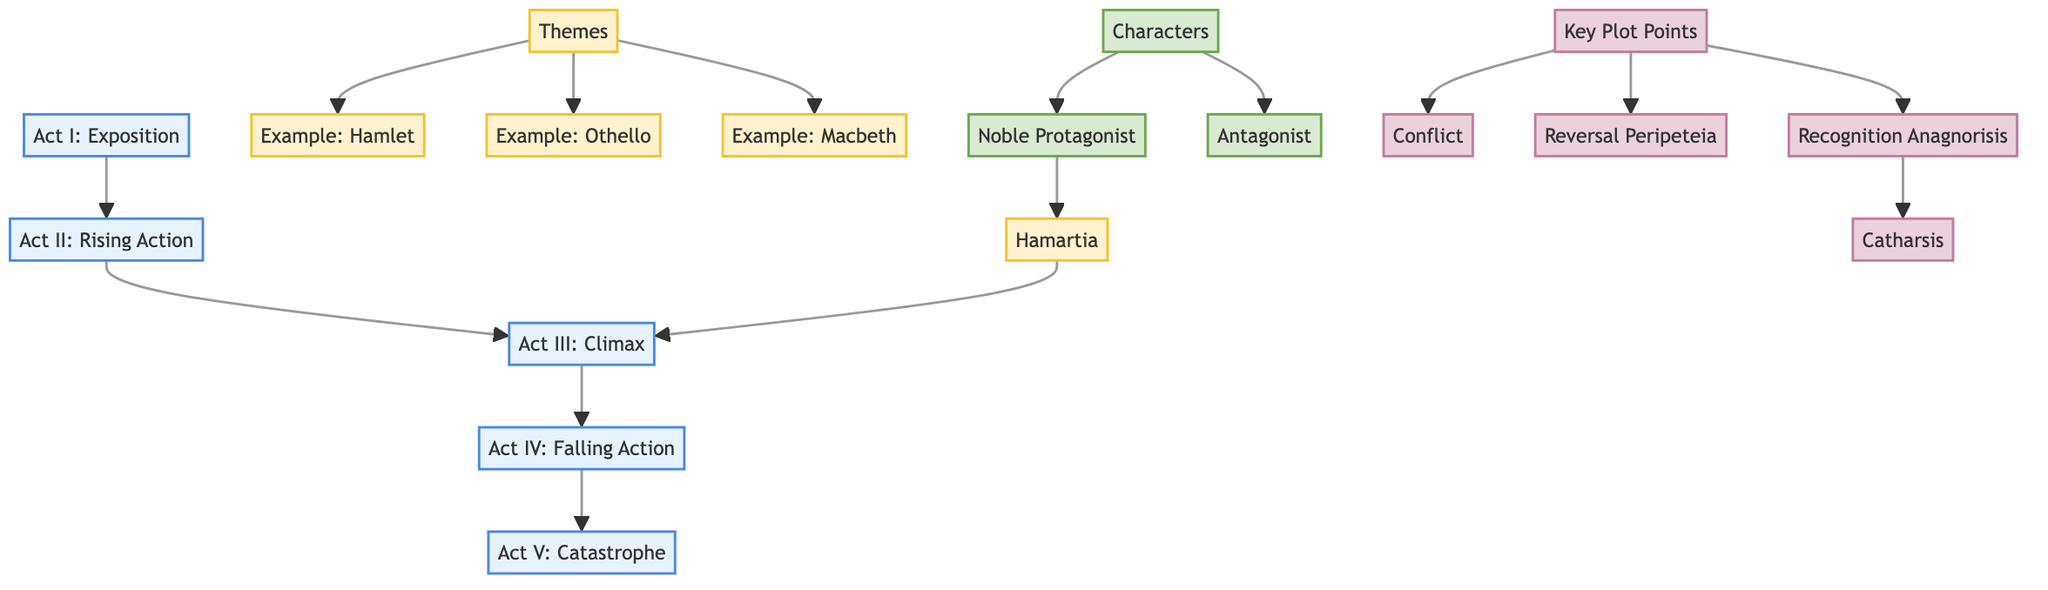What are the five acts in the diagram? The diagram lists five acts: Exposition, Rising Action, Climax, Falling Action, and Catastrophe. These can be found in sequential order along the left side of the diagram under the section labeled "Acts."
Answer: Exposition, Rising Action, Climax, Falling Action, Catastrophe Which theme is connected to the Climax? In the diagram, the theme "Hamartia" points directly to the Climax, indicating that this element is significant at this point of the plot structure. This relationship is shown by the directional arrow from "Hamartia" to "Act III: Climax."
Answer: Hamartia How many characters are identified in the diagram? The diagram identifies two types of characters: Noble Protagonist and Antagonist. These two categories are indicated under the section labeled "Characters," confirming there are two distinct character types present.
Answer: 2 What is the relationship between Recognition Anagnorisis and Catharsis? The diagram illustrates that Recognition Anagnorisis leads directly to Catharsis, which shows a cause-and-effect relationship between these two plot points in the structure of Shakespearean tragedies. The arrow flows from "Recognition Anagnorisis" to "Catharsis."
Answer: Recognition Anagnorisis → Catharsis Which examples are provided under the Themes section? The diagram lists three examples under the "Themes" section: Hamlet, Othello, and Macbeth. This information is located in the area dedicated to themes in the diagram, showing specific works that illustrate the themes discussed.
Answer: Hamlet, Othello, Macbeth How does the Noble Protagonist relate to Hamartia? The diagram indicates that the Noble Protagonist is connected to Hamartia, demonstrating that the fatal flaw or error (Hamartia) is a characteristic of the protagonist in Shakespearean tragedy. The flow from "Noble Protagonist" leads to "Hamartia."
Answer: Noble Protagonist → Hamartia 